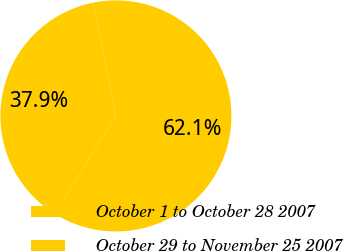<chart> <loc_0><loc_0><loc_500><loc_500><pie_chart><fcel>October 1 to October 28 2007<fcel>October 29 to November 25 2007<nl><fcel>62.06%<fcel>37.94%<nl></chart> 